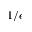<formula> <loc_0><loc_0><loc_500><loc_500>1 / \epsilon</formula> 